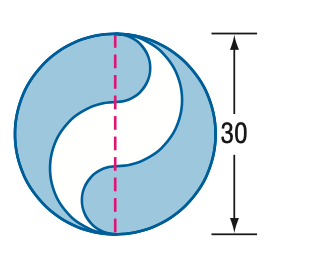What mathematical concepts does this problem involve? This problem involves several mathematical concepts, including the area calculation of circles and parts of circles (semicircles and quarter circles), understanding of π (pi), and the concept of subtraction of areas in plane geometry to find the area of composite figures. 